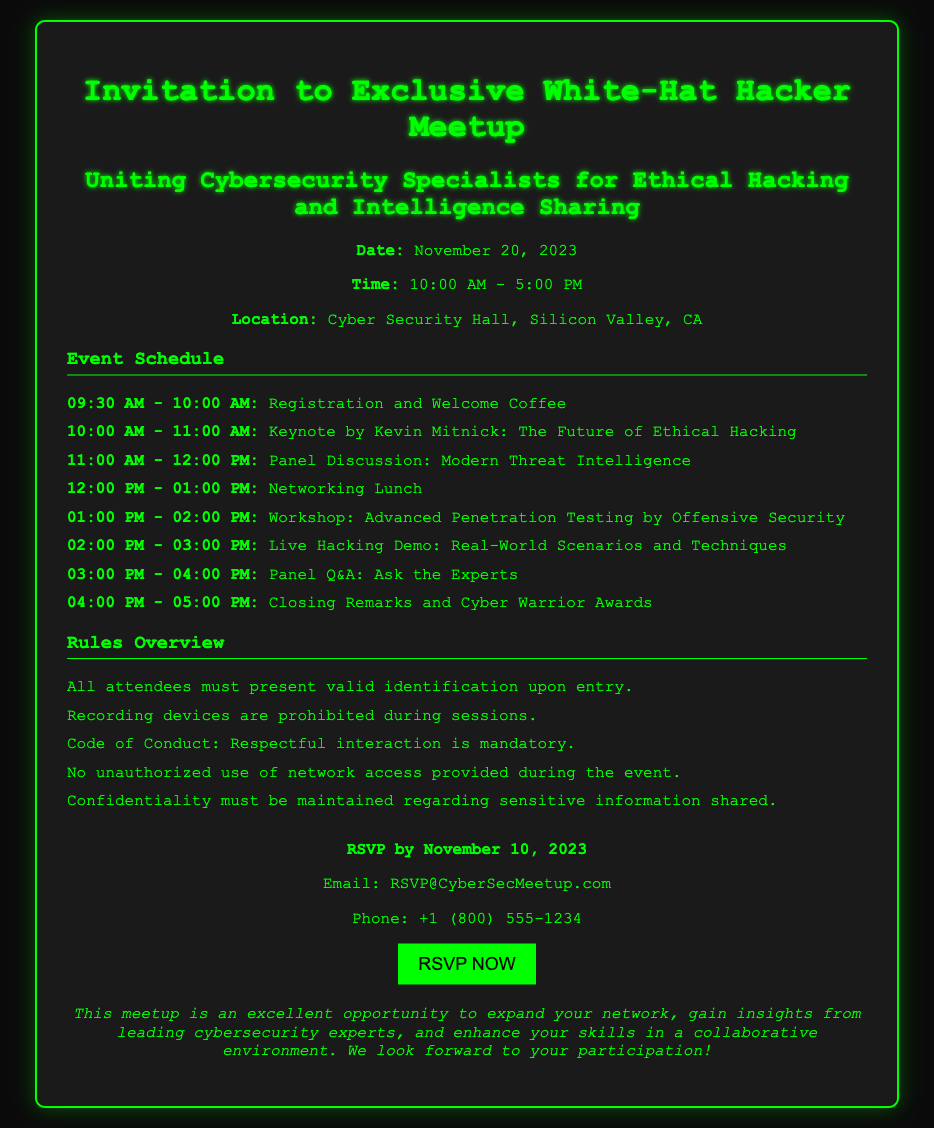what is the date of the meetup? The date mentioned in the document for the meetup is November 20, 2023.
Answer: November 20, 2023 what is the location of the event? The document specifies that the location of the event is Cyber Security Hall, Silicon Valley, CA.
Answer: Cyber Security Hall, Silicon Valley, CA who is giving the keynote speech? The document states that Kevin Mitnick is the speaker for the keynote titled "The Future of Ethical Hacking."
Answer: Kevin Mitnick what time does the registration start? According to the document, registration starts at 09:30 AM.
Answer: 09:30 AM how long is the networking lunch? The document indicates that the networking lunch lasts for 1 hour, from 12:00 PM to 01:00 PM.
Answer: 1 hour how many panels are included in the schedule? The document lists two panels: one for discussion and one for Q&A, making a total of two panels in the schedule.
Answer: 2 what must attendees present upon entry? The document requires all attendees to present valid identification upon entry.
Answer: valid identification when is the RSVP deadline? The document states that the RSVP must be completed by November 10, 2023.
Answer: November 10, 2023 what is the main purpose of the meetup? The document describes the purpose of the meetup as uniting cybersecurity specialists for ethical hacking and intelligence sharing.
Answer: uniting cybersecurity specialists for ethical hacking and intelligence sharing 